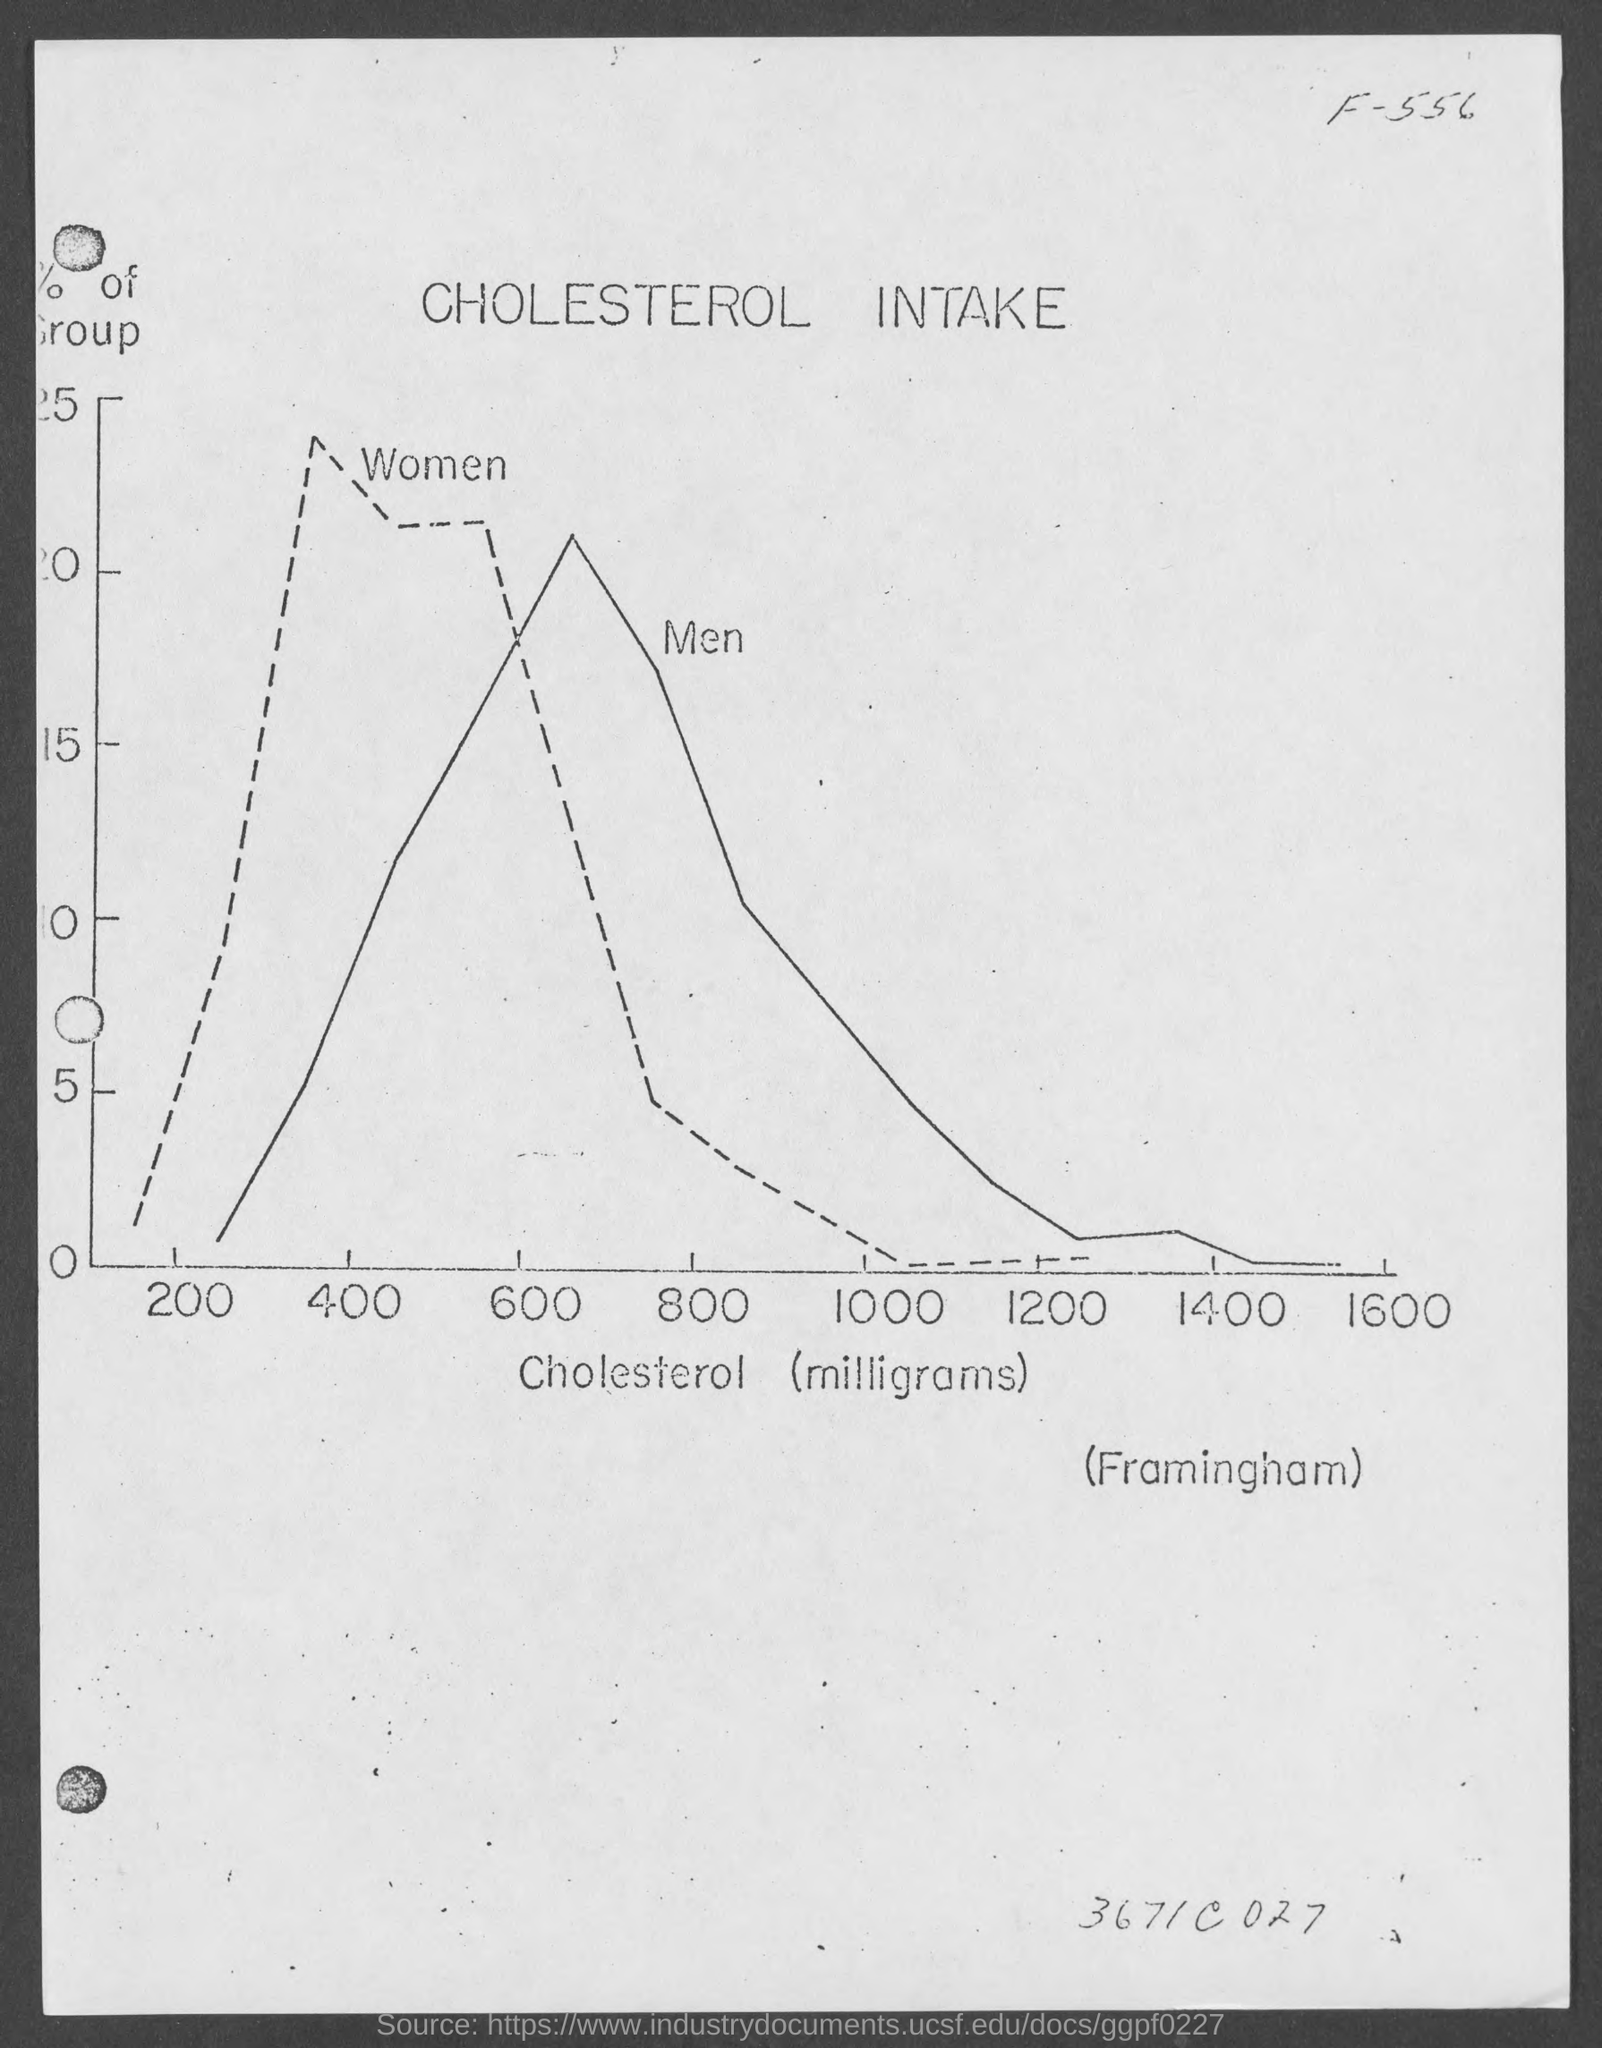What is the title of the graph?
Provide a succinct answer. Cholesterol Intake. What is the variable on X axis of the graph?
Your answer should be very brief. Cholesterol (milligrams). Which group does the dotted line represent?
Ensure brevity in your answer.  Women. Which group does the solid line represent?
Your answer should be very brief. Men. 